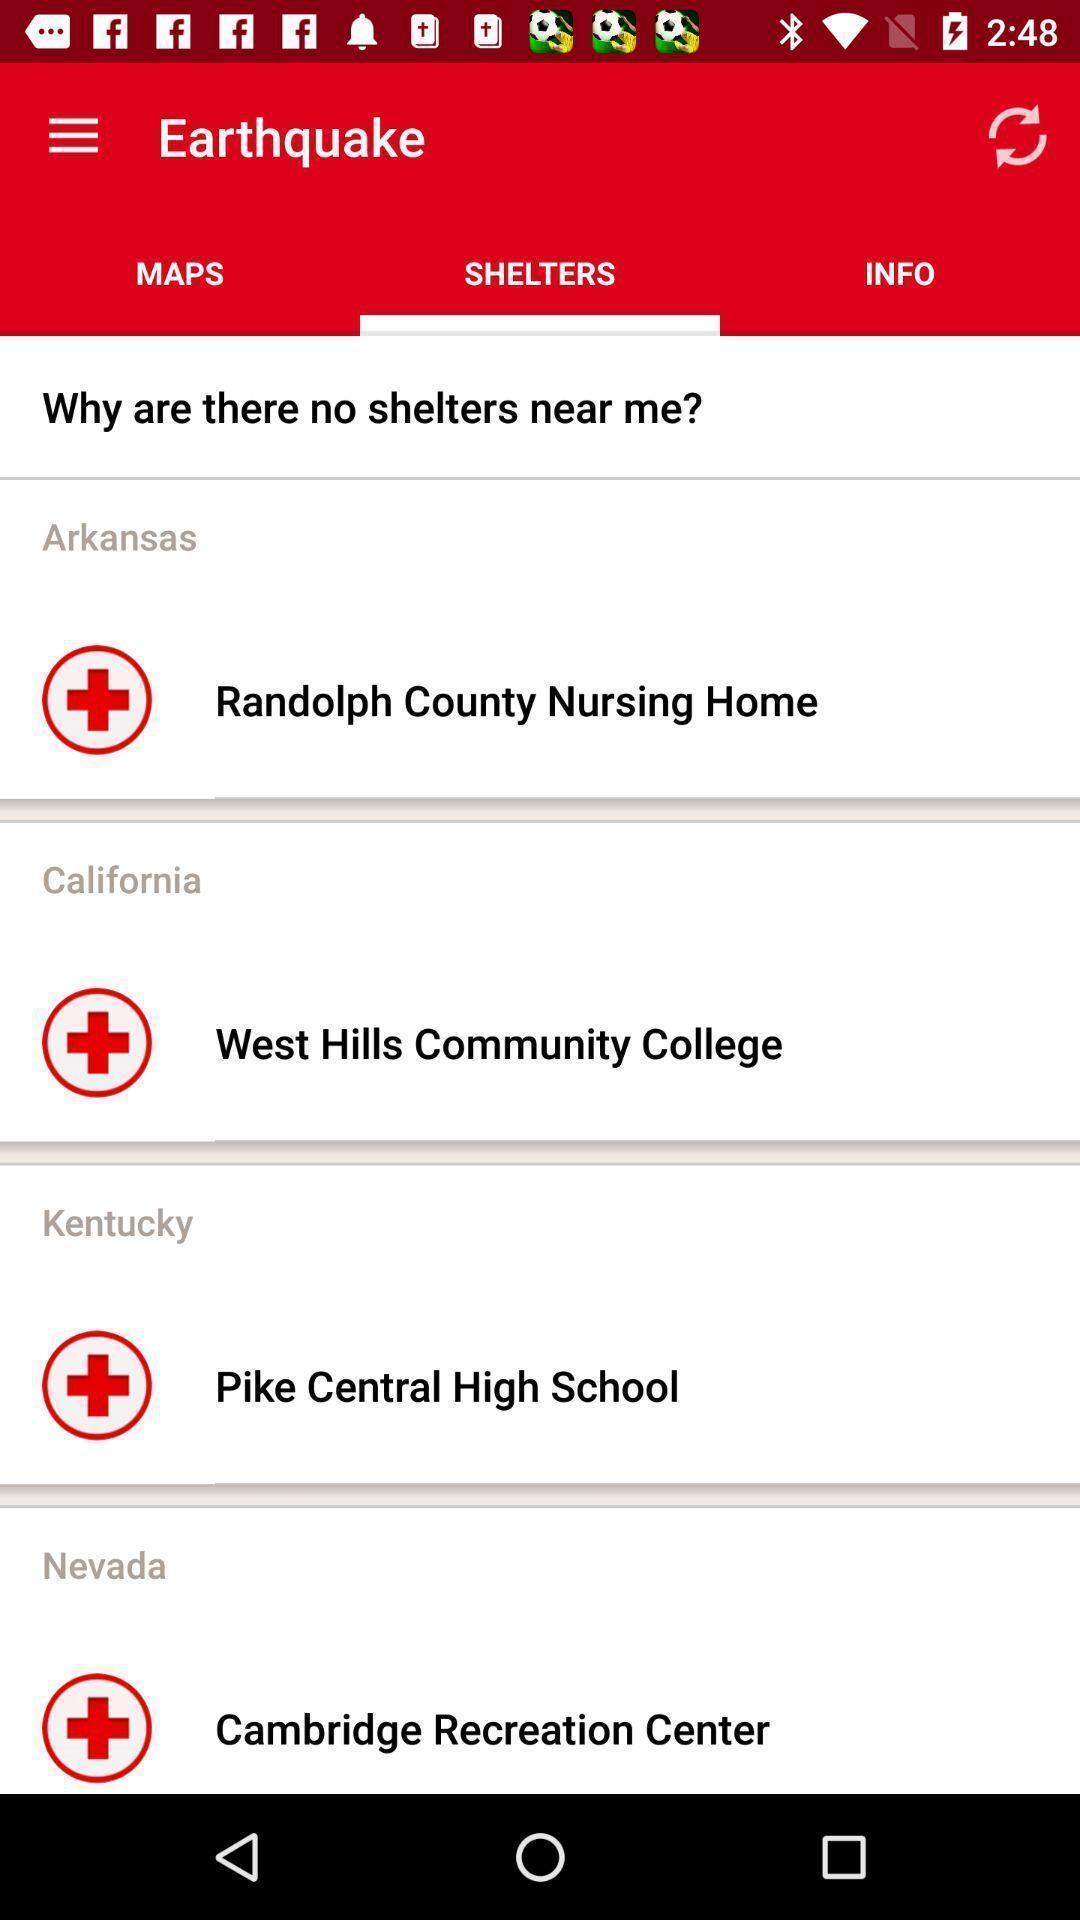Give me a summary of this screen capture. Screen displaying the shelters page. 